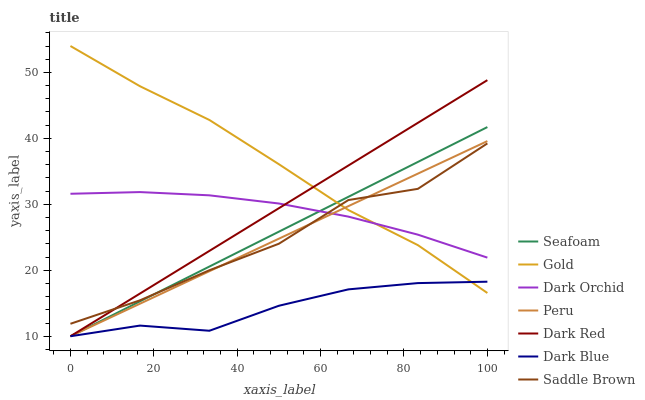Does Dark Red have the minimum area under the curve?
Answer yes or no. No. Does Dark Red have the maximum area under the curve?
Answer yes or no. No. Is Dark Red the smoothest?
Answer yes or no. No. Is Dark Red the roughest?
Answer yes or no. No. Does Dark Orchid have the lowest value?
Answer yes or no. No. Does Dark Red have the highest value?
Answer yes or no. No. Is Dark Blue less than Dark Orchid?
Answer yes or no. Yes. Is Saddle Brown greater than Dark Blue?
Answer yes or no. Yes. Does Dark Blue intersect Dark Orchid?
Answer yes or no. No. 